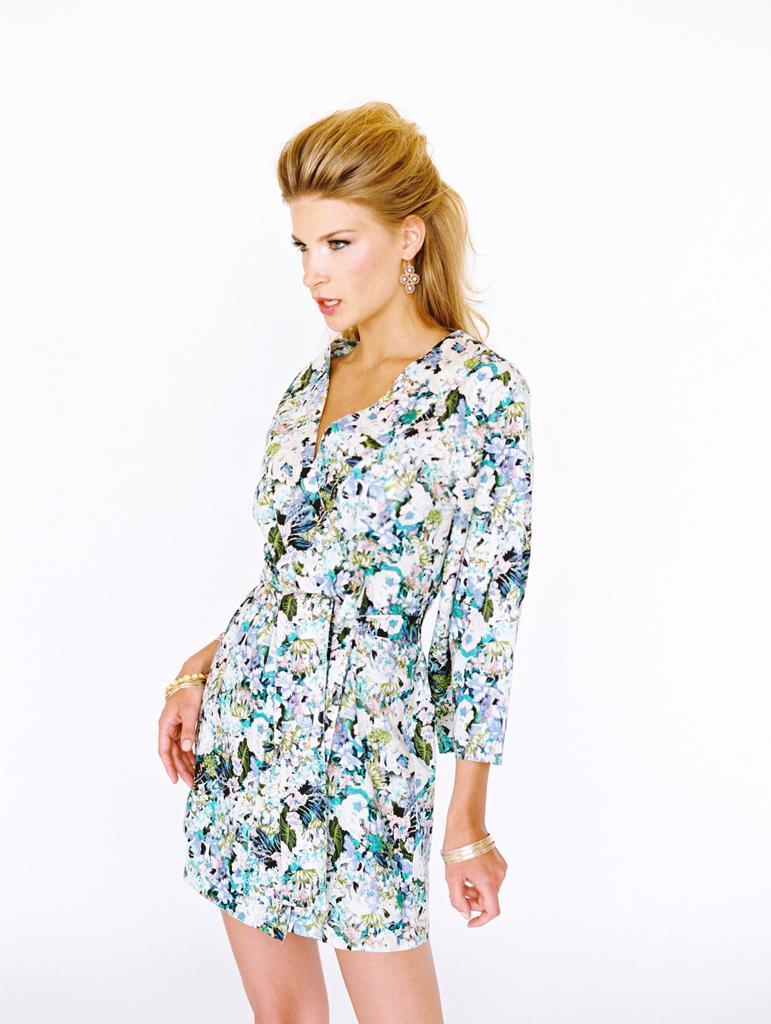Can you describe this image briefly? In this picture we can observe woman standing, wearing white color dress. We can observe yellow color hair. The background is in white color. 